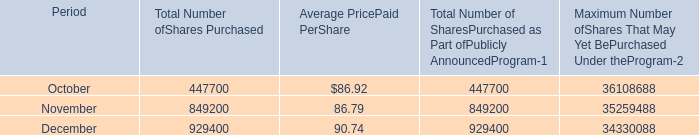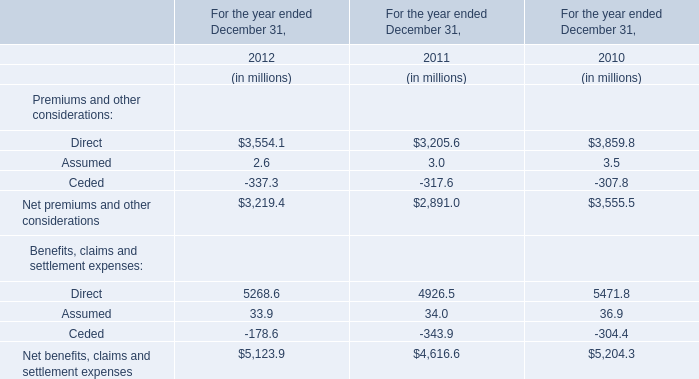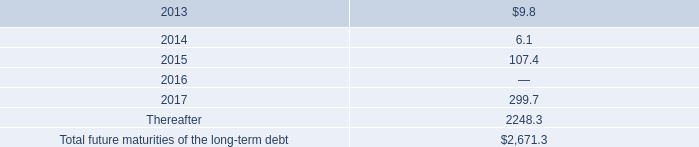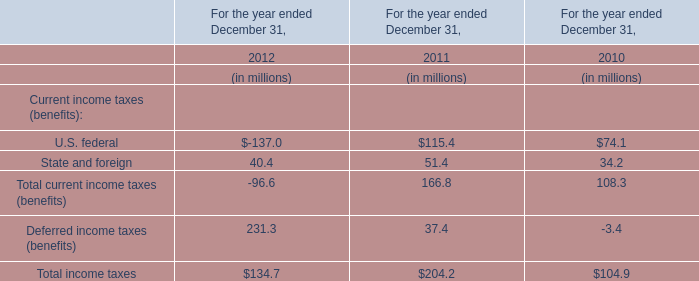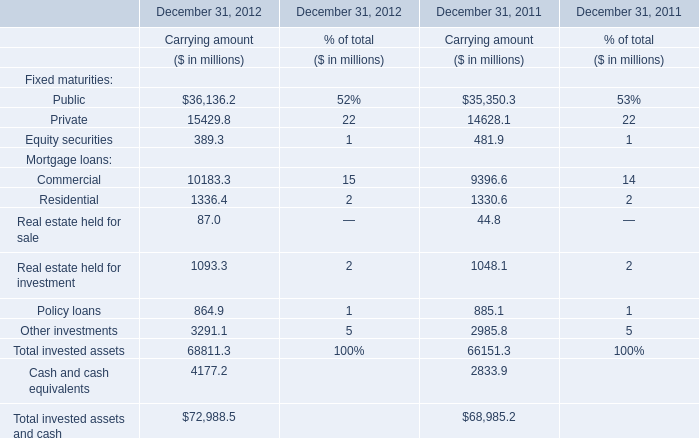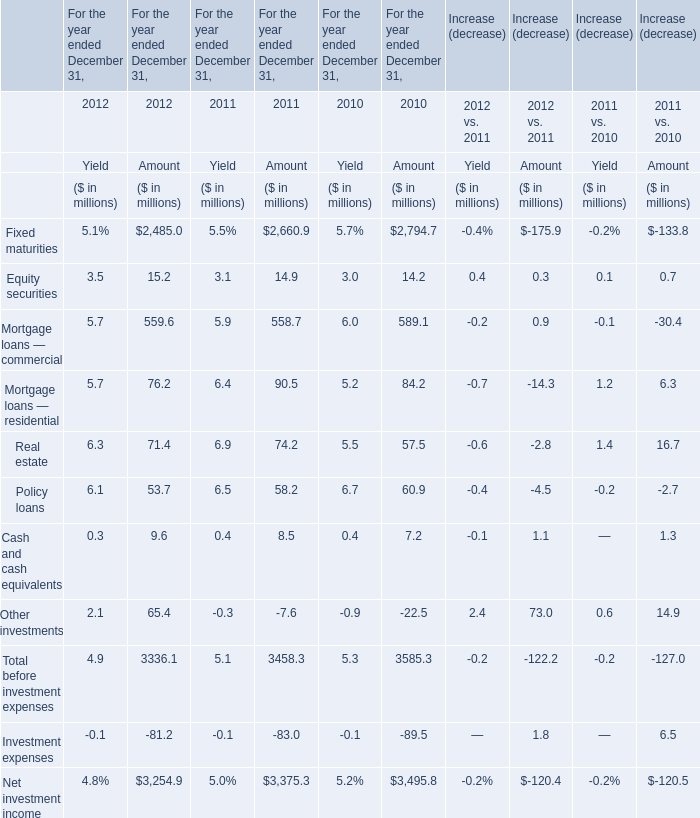What is the proportion of Equity securities to the total in 2011 
Computations: (14.9 / 3375.3)
Answer: 0.00441. 